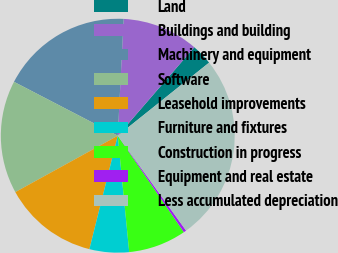Convert chart to OTSL. <chart><loc_0><loc_0><loc_500><loc_500><pie_chart><fcel>Land<fcel>Buildings and building<fcel>Machinery and equipment<fcel>Software<fcel>Leasehold improvements<fcel>Furniture and fixtures<fcel>Construction in progress<fcel>Equipment and real estate<fcel>Less accumulated depreciation<nl><fcel>2.91%<fcel>10.55%<fcel>18.18%<fcel>15.63%<fcel>13.09%<fcel>5.46%<fcel>8.0%<fcel>0.37%<fcel>25.81%<nl></chart> 